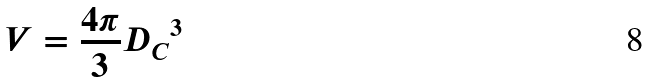Convert formula to latex. <formula><loc_0><loc_0><loc_500><loc_500>V = \frac { 4 \pi } { 3 } { D _ { C } } ^ { 3 }</formula> 